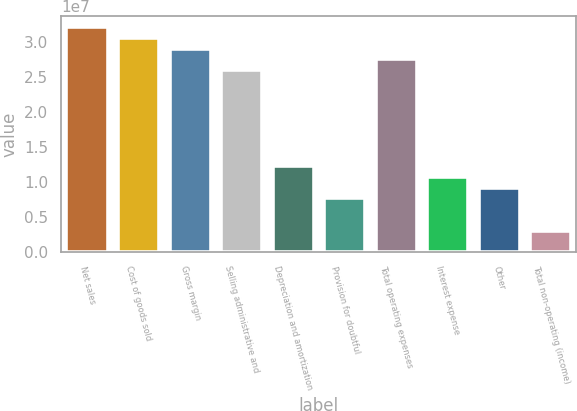<chart> <loc_0><loc_0><loc_500><loc_500><bar_chart><fcel>Net sales<fcel>Cost of goods sold<fcel>Gross margin<fcel>Selling administrative and<fcel>Depreciation and amortization<fcel>Provision for doubtful<fcel>Total operating expenses<fcel>Interest expense<fcel>Other<fcel>Total non-operating (income)<nl><fcel>3.20881e+07<fcel>3.05601e+07<fcel>2.90321e+07<fcel>2.59761e+07<fcel>1.2224e+07<fcel>7.64002e+06<fcel>2.75041e+07<fcel>1.0696e+07<fcel>9.16803e+06<fcel>3.05601e+06<nl></chart> 